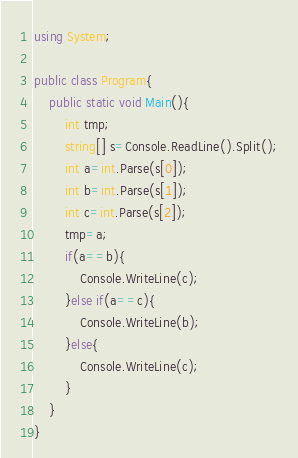<code> <loc_0><loc_0><loc_500><loc_500><_C#_>using System;

public class Program{
    public static void Main(){
        int tmp;
        string[] s=Console.ReadLine().Split();
        int a=int.Parse(s[0]);
        int b=int.Parse(s[1]);
        int c=int.Parse(s[2]);
        tmp=a;
        if(a==b){
            Console.WriteLine(c);
        }else if(a==c){
            Console.WriteLine(b);
        }else{
            Console.WriteLine(c);
        }
    }
}
</code> 